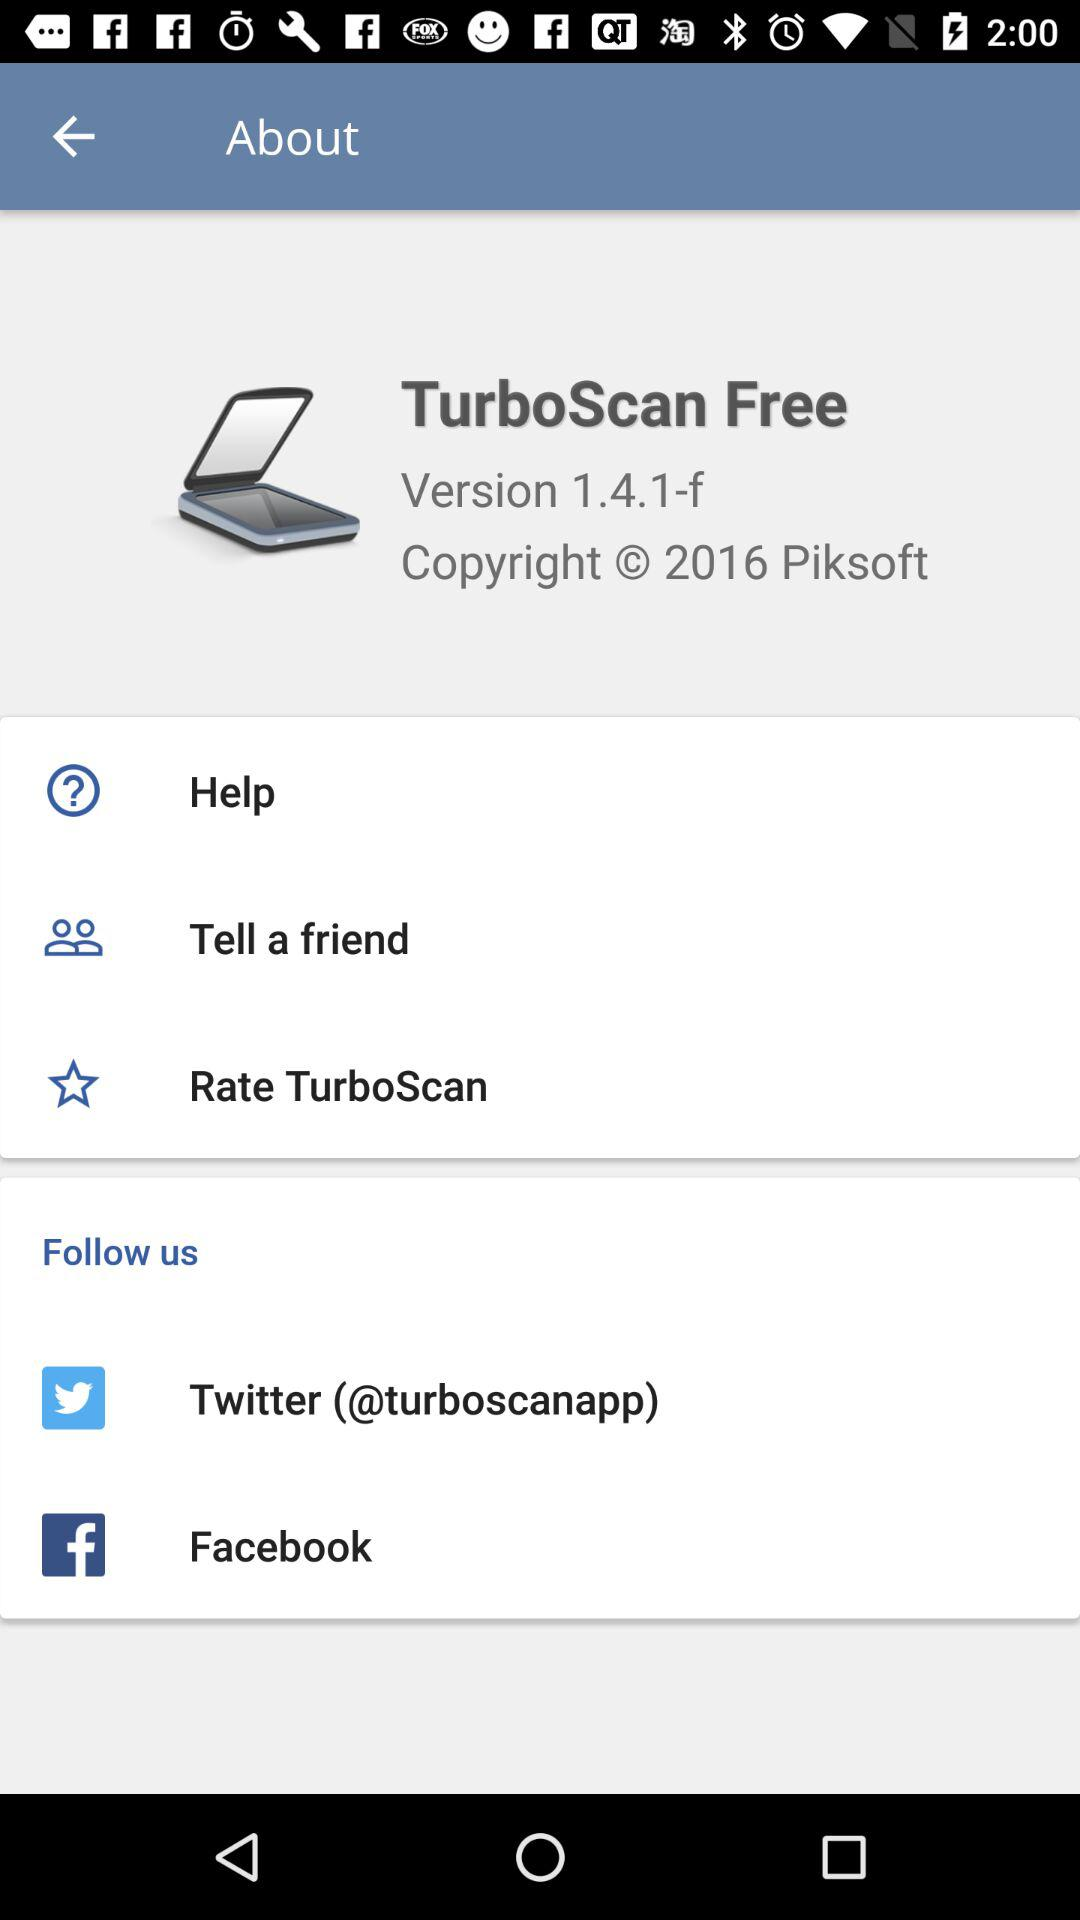Which version is it? The version is 1.4.1-f. 